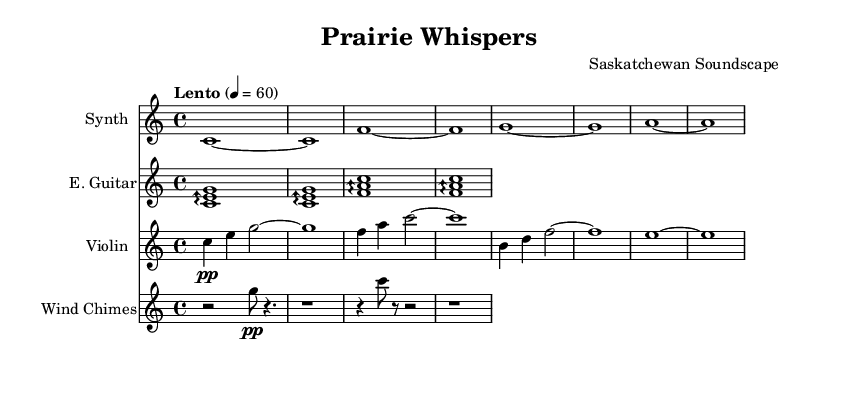What is the key signature of this music? The key signature is C major, which has no sharps or flats.
Answer: C major What is the time signature of this piece? The time signature is indicated as 4/4, meaning there are four beats in each measure and the quarter note gets one beat.
Answer: 4/4 What is the tempo marking of the piece? The tempo marking is "Lento," which indicates a slow tempo, typically around 60 beats per minute, as noted in the sheet music.
Answer: Lento Which instrument plays the arpeggios? The electric guitar section features arpeggiated chords, indicated by the arpeggio symbol, which is characteristic of the instrument's part.
Answer: Electric Guitar How many measures are in the synthesizer part? The synthesizer part contains a total of 8 measures, as seen in the notated music, with each measure denoted by a vertical bar line.
Answer: 8 measures What dynamic marking is indicated for the wind chimes? The wind chimes are marked with the dynamic "pp," which stands for pianissimo, indicating that they should be played very softly.
Answer: pp What type of texture does the violin part create in this composition? The violin part features melodic lines accompanied by sustained notes in other instruments, creating a polyphonic texture characteristic of ambient soundscapes.
Answer: Polyphonic 